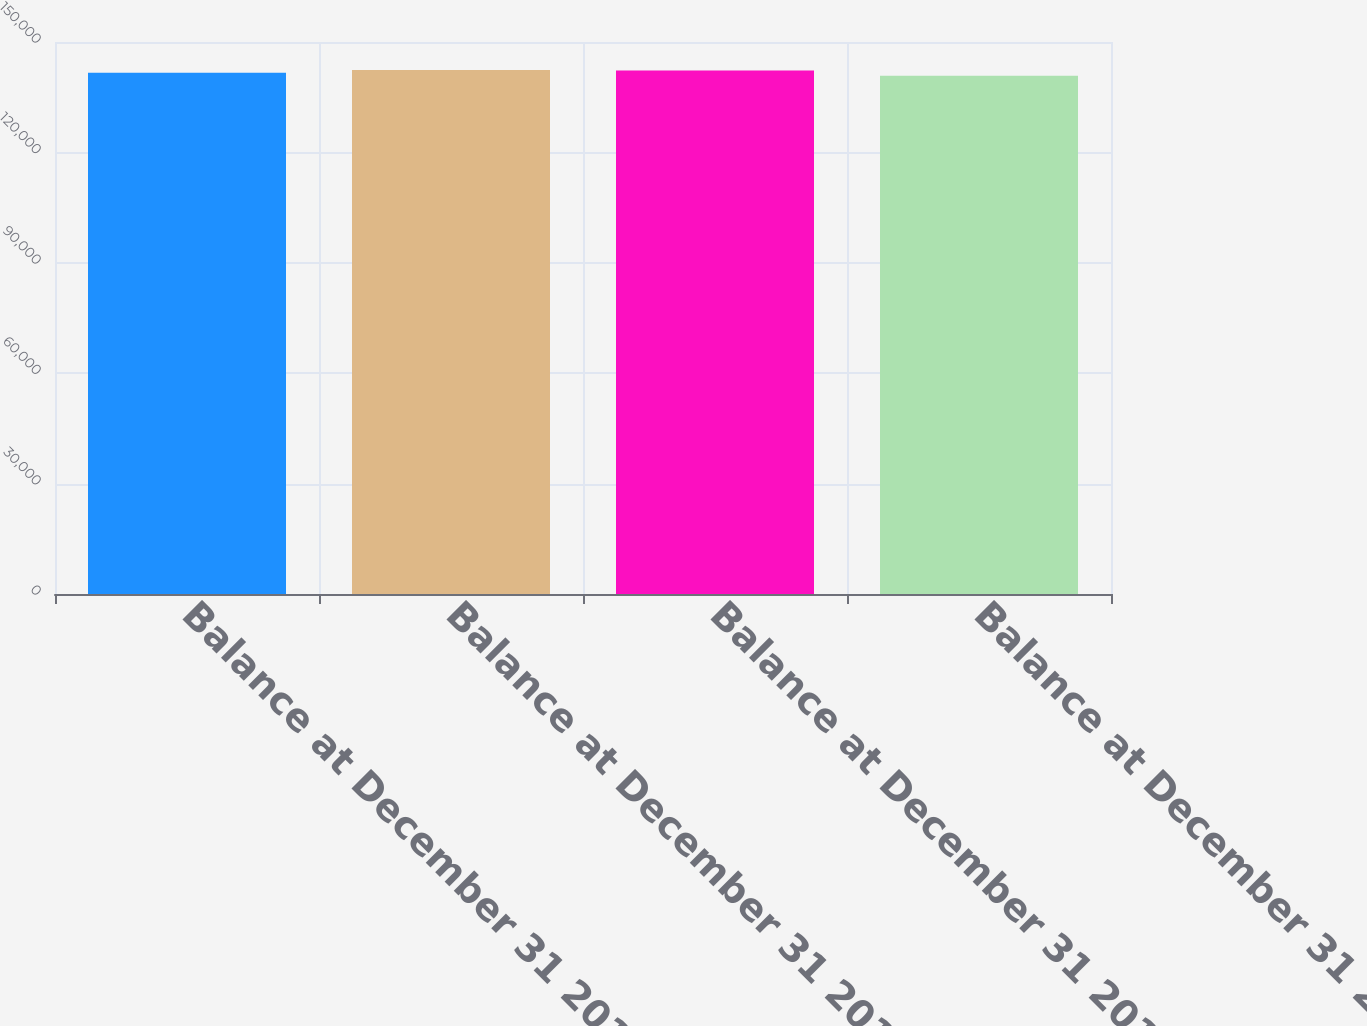Convert chart to OTSL. <chart><loc_0><loc_0><loc_500><loc_500><bar_chart><fcel>Balance at December 31 2011<fcel>Balance at December 31 2012<fcel>Balance at December 31 2013<fcel>Balance at December 31 2014<nl><fcel>141632<fcel>142389<fcel>142241<fcel>140844<nl></chart> 